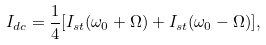<formula> <loc_0><loc_0><loc_500><loc_500>I _ { d c } = \frac { 1 } { 4 } [ I _ { s t } ( \omega _ { 0 } + \Omega ) + I _ { s t } ( \omega _ { 0 } - \Omega ) ] ,</formula> 